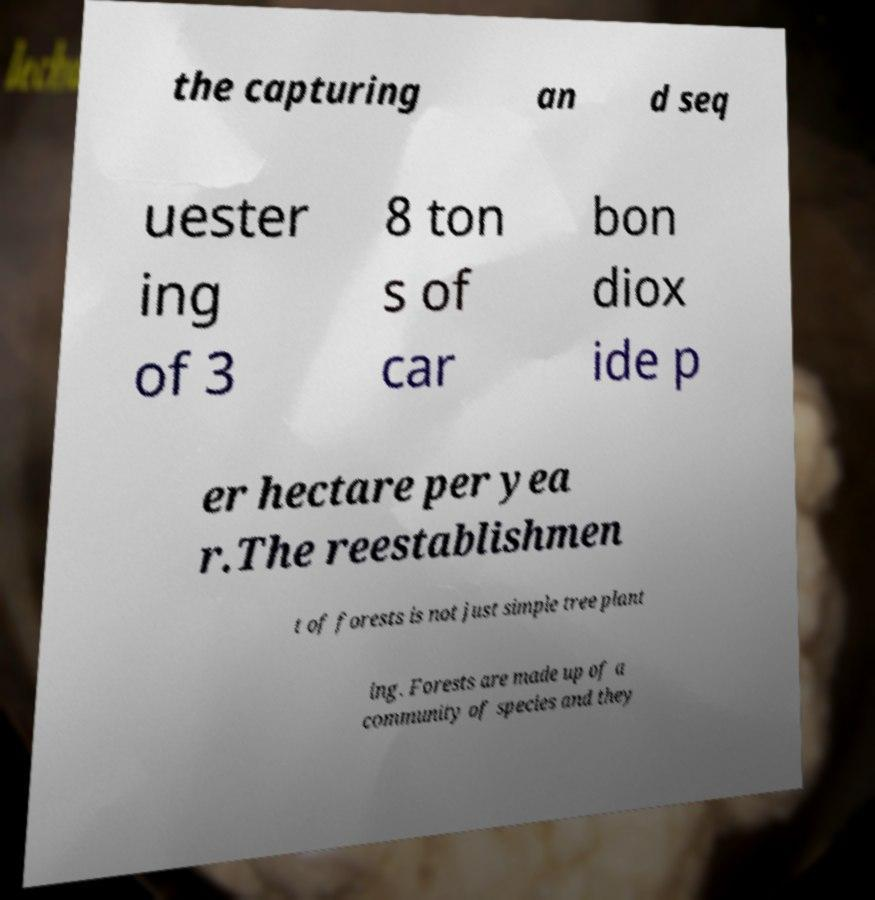There's text embedded in this image that I need extracted. Can you transcribe it verbatim? the capturing an d seq uester ing of 3 8 ton s of car bon diox ide p er hectare per yea r.The reestablishmen t of forests is not just simple tree plant ing. Forests are made up of a community of species and they 